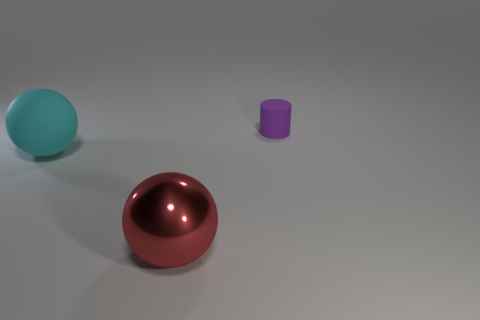Is there any other thing that is the same size as the matte cylinder?
Keep it short and to the point. No. Is the number of matte balls in front of the red sphere less than the number of big cyan spheres that are behind the large cyan ball?
Your answer should be compact. No. Do the object that is to the left of the large metal thing and the thing that is to the right of the big red sphere have the same color?
Offer a very short reply. No. There is a thing that is both on the right side of the large cyan sphere and in front of the small object; what material is it?
Offer a very short reply. Metal. Is there a gray object?
Your response must be concise. No. There is a cyan object that is the same material as the cylinder; what is its shape?
Provide a short and direct response. Sphere. There is a red metal thing; is it the same shape as the object right of the metal ball?
Offer a very short reply. No. The big thing that is to the left of the ball in front of the big cyan rubber sphere is made of what material?
Your answer should be very brief. Rubber. How many other things are there of the same shape as the red metallic thing?
Keep it short and to the point. 1. There is a rubber thing that is in front of the purple cylinder; is it the same shape as the thing behind the big matte thing?
Give a very brief answer. No. 